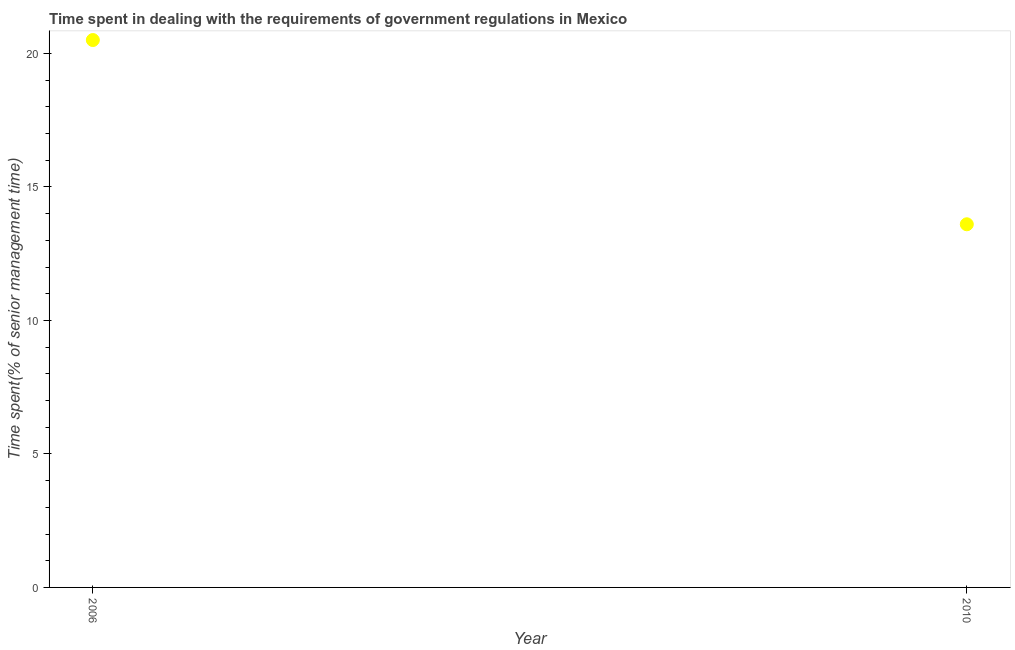Across all years, what is the minimum time spent in dealing with government regulations?
Make the answer very short. 13.6. In which year was the time spent in dealing with government regulations maximum?
Your response must be concise. 2006. In which year was the time spent in dealing with government regulations minimum?
Provide a short and direct response. 2010. What is the sum of the time spent in dealing with government regulations?
Your answer should be very brief. 34.1. What is the difference between the time spent in dealing with government regulations in 2006 and 2010?
Provide a succinct answer. 6.9. What is the average time spent in dealing with government regulations per year?
Keep it short and to the point. 17.05. What is the median time spent in dealing with government regulations?
Your answer should be very brief. 17.05. Do a majority of the years between 2006 and 2010 (inclusive) have time spent in dealing with government regulations greater than 3 %?
Make the answer very short. Yes. What is the ratio of the time spent in dealing with government regulations in 2006 to that in 2010?
Ensure brevity in your answer.  1.51. In how many years, is the time spent in dealing with government regulations greater than the average time spent in dealing with government regulations taken over all years?
Keep it short and to the point. 1. Does the time spent in dealing with government regulations monotonically increase over the years?
Provide a short and direct response. No. How many dotlines are there?
Ensure brevity in your answer.  1. Does the graph contain grids?
Your answer should be compact. No. What is the title of the graph?
Your response must be concise. Time spent in dealing with the requirements of government regulations in Mexico. What is the label or title of the X-axis?
Offer a very short reply. Year. What is the label or title of the Y-axis?
Your answer should be compact. Time spent(% of senior management time). What is the difference between the Time spent(% of senior management time) in 2006 and 2010?
Offer a terse response. 6.9. What is the ratio of the Time spent(% of senior management time) in 2006 to that in 2010?
Provide a succinct answer. 1.51. 